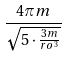Convert formula to latex. <formula><loc_0><loc_0><loc_500><loc_500>\frac { 4 \pi m } { \sqrt { 5 \cdot \frac { 3 m } { r o ^ { 3 } } } }</formula> 